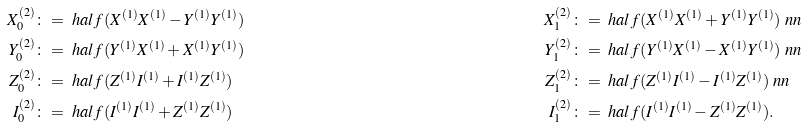Convert formula to latex. <formula><loc_0><loc_0><loc_500><loc_500>X _ { 0 } ^ { ( 2 ) } & \colon = \ h a l f ( X ^ { ( 1 ) } X ^ { ( 1 ) } - Y ^ { ( 1 ) } Y ^ { ( 1 ) } ) & X _ { 1 } ^ { ( 2 ) } & \colon = \ h a l f ( X ^ { ( 1 ) } X ^ { ( 1 ) } + Y ^ { ( 1 ) } Y ^ { ( 1 ) } ) \ n n \\ Y _ { 0 } ^ { ( 2 ) } & \colon = \ h a l f ( Y ^ { ( 1 ) } X ^ { ( 1 ) } + X ^ { ( 1 ) } Y ^ { ( 1 ) } ) & { Y } _ { 1 } ^ { ( 2 ) } & \colon = \ h a l f ( Y ^ { ( 1 ) } X ^ { ( 1 ) } - X ^ { ( 1 ) } Y ^ { ( 1 ) } ) \ n n \\ Z _ { 0 } ^ { ( 2 ) } & \colon = \ h a l f ( Z ^ { ( 1 ) } I ^ { ( 1 ) } + I ^ { ( 1 ) } Z ^ { ( 1 ) } ) & { Z } _ { 1 } ^ { ( 2 ) } & \colon = \ h a l f ( Z ^ { ( 1 ) } I ^ { ( 1 ) } - I ^ { ( 1 ) } Z ^ { ( 1 ) } ) \ n n \\ I _ { 0 } ^ { ( 2 ) } & \colon = \ h a l f ( I ^ { ( 1 ) } I ^ { ( 1 ) } + Z ^ { ( 1 ) } Z ^ { ( 1 ) } ) & { I } _ { 1 } ^ { ( 2 ) } & \colon = \ h a l f ( I ^ { ( 1 ) } I ^ { ( 1 ) } - Z ^ { ( 1 ) } Z ^ { ( 1 ) } ) .</formula> 